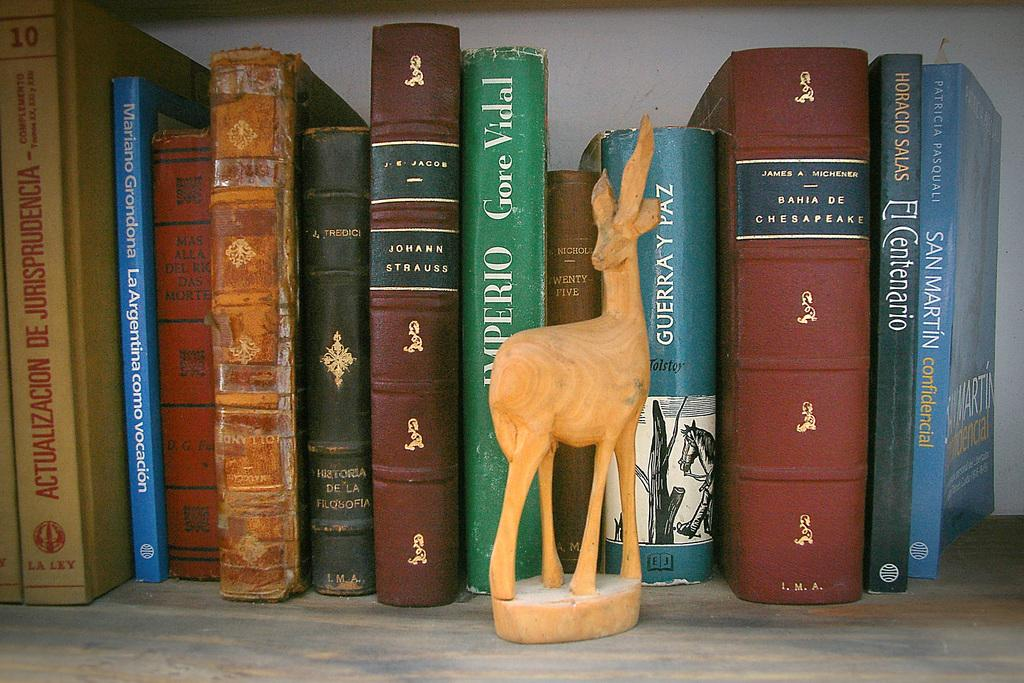Provide a one-sentence caption for the provided image. A collection of books includes one by Gore Vidal. 